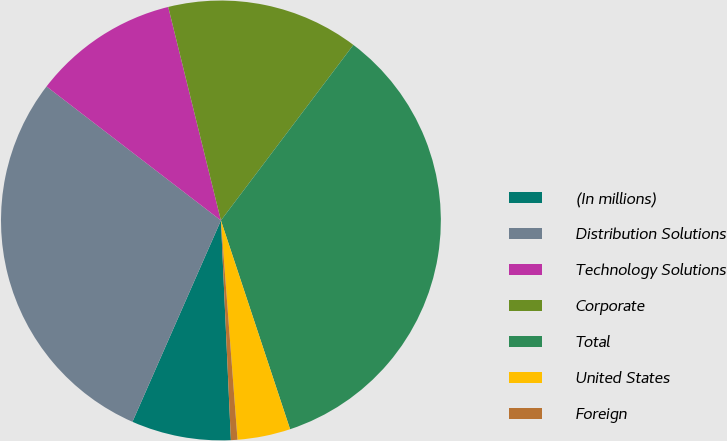Convert chart. <chart><loc_0><loc_0><loc_500><loc_500><pie_chart><fcel>(In millions)<fcel>Distribution Solutions<fcel>Technology Solutions<fcel>Corporate<fcel>Total<fcel>United States<fcel>Foreign<nl><fcel>7.31%<fcel>28.84%<fcel>10.72%<fcel>14.14%<fcel>34.62%<fcel>3.89%<fcel>0.48%<nl></chart> 